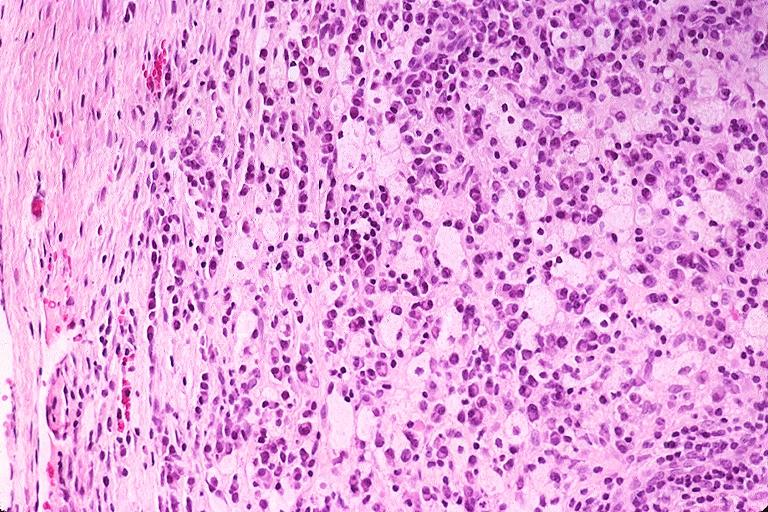what does this image show?
Answer the question using a single word or phrase. Periapical granuloma 